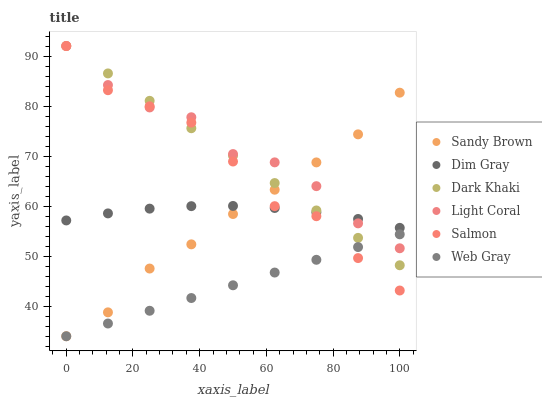Does Web Gray have the minimum area under the curve?
Answer yes or no. Yes. Does Light Coral have the maximum area under the curve?
Answer yes or no. Yes. Does Dim Gray have the minimum area under the curve?
Answer yes or no. No. Does Dim Gray have the maximum area under the curve?
Answer yes or no. No. Is Web Gray the smoothest?
Answer yes or no. Yes. Is Salmon the roughest?
Answer yes or no. Yes. Is Dim Gray the smoothest?
Answer yes or no. No. Is Dim Gray the roughest?
Answer yes or no. No. Does Web Gray have the lowest value?
Answer yes or no. Yes. Does Salmon have the lowest value?
Answer yes or no. No. Does Dark Khaki have the highest value?
Answer yes or no. Yes. Does Dim Gray have the highest value?
Answer yes or no. No. Is Web Gray less than Dim Gray?
Answer yes or no. Yes. Is Dim Gray greater than Web Gray?
Answer yes or no. Yes. Does Light Coral intersect Web Gray?
Answer yes or no. Yes. Is Light Coral less than Web Gray?
Answer yes or no. No. Is Light Coral greater than Web Gray?
Answer yes or no. No. Does Web Gray intersect Dim Gray?
Answer yes or no. No. 